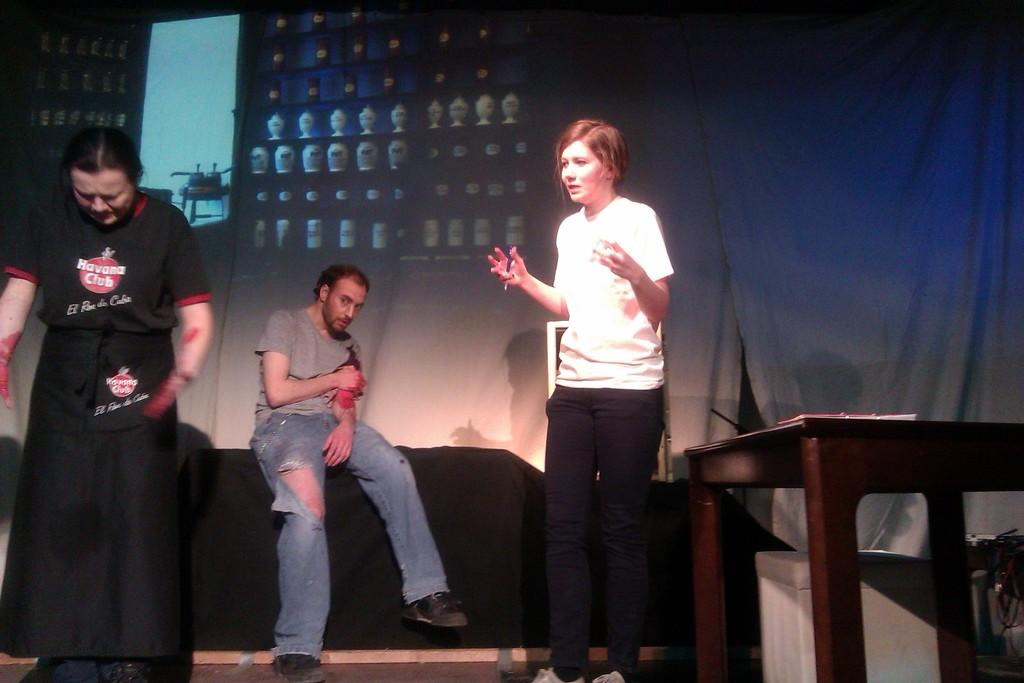How many people are present in the image? There are three people in the image: two women and one man. What are the women doing in the image? The women are standing in the image. What is the man doing in the image? The man is sitting in the image. What can be seen in the background of the image? There is a curtain in the background of the image. How many clocks are hanging on the curtain in the image? There are no clocks visible in the image, and the curtain is not mentioned as having any clocks hanging on it. 